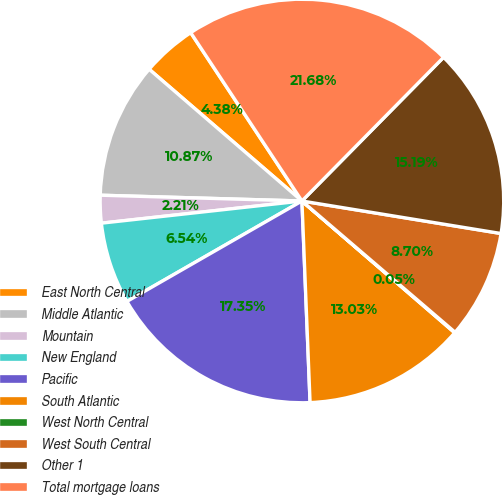<chart> <loc_0><loc_0><loc_500><loc_500><pie_chart><fcel>East North Central<fcel>Middle Atlantic<fcel>Mountain<fcel>New England<fcel>Pacific<fcel>South Atlantic<fcel>West North Central<fcel>West South Central<fcel>Other 1<fcel>Total mortgage loans<nl><fcel>4.38%<fcel>10.87%<fcel>2.21%<fcel>6.54%<fcel>17.35%<fcel>13.03%<fcel>0.05%<fcel>8.7%<fcel>15.19%<fcel>21.68%<nl></chart> 